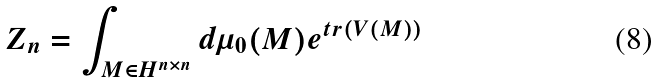<formula> <loc_0><loc_0><loc_500><loc_500>Z _ { n } = \int _ { M \in H ^ { n \times n } } d \mu _ { 0 } ( M ) e ^ { { t r } ( V ( M ) ) }</formula> 